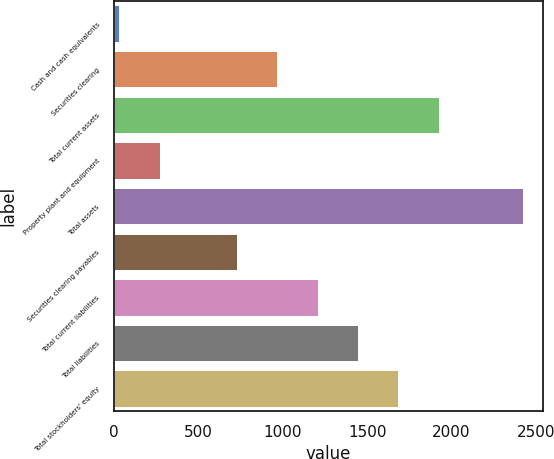Convert chart. <chart><loc_0><loc_0><loc_500><loc_500><bar_chart><fcel>Cash and cash equivalents<fcel>Securities clearing<fcel>Total current assets<fcel>Property plant and equipment<fcel>Total assets<fcel>Securities clearing payables<fcel>Total current liabilities<fcel>Total liabilities<fcel>Total stockholders' equity<nl><fcel>31.6<fcel>968.21<fcel>1924.65<fcel>270.71<fcel>2422.7<fcel>729.1<fcel>1207.32<fcel>1446.43<fcel>1685.54<nl></chart> 